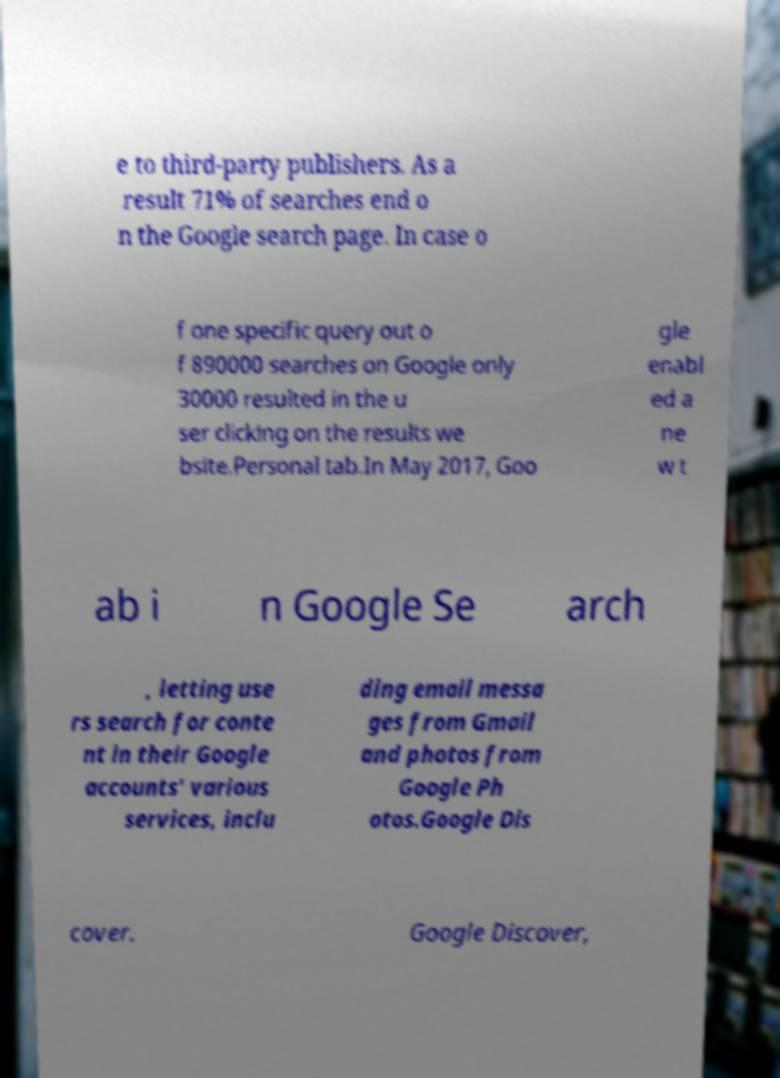I need the written content from this picture converted into text. Can you do that? e to third-party publishers. As a result 71% of searches end o n the Google search page. In case o f one specific query out o f 890000 searches on Google only 30000 resulted in the u ser clicking on the results we bsite.Personal tab.In May 2017, Goo gle enabl ed a ne w t ab i n Google Se arch , letting use rs search for conte nt in their Google accounts' various services, inclu ding email messa ges from Gmail and photos from Google Ph otos.Google Dis cover. Google Discover, 